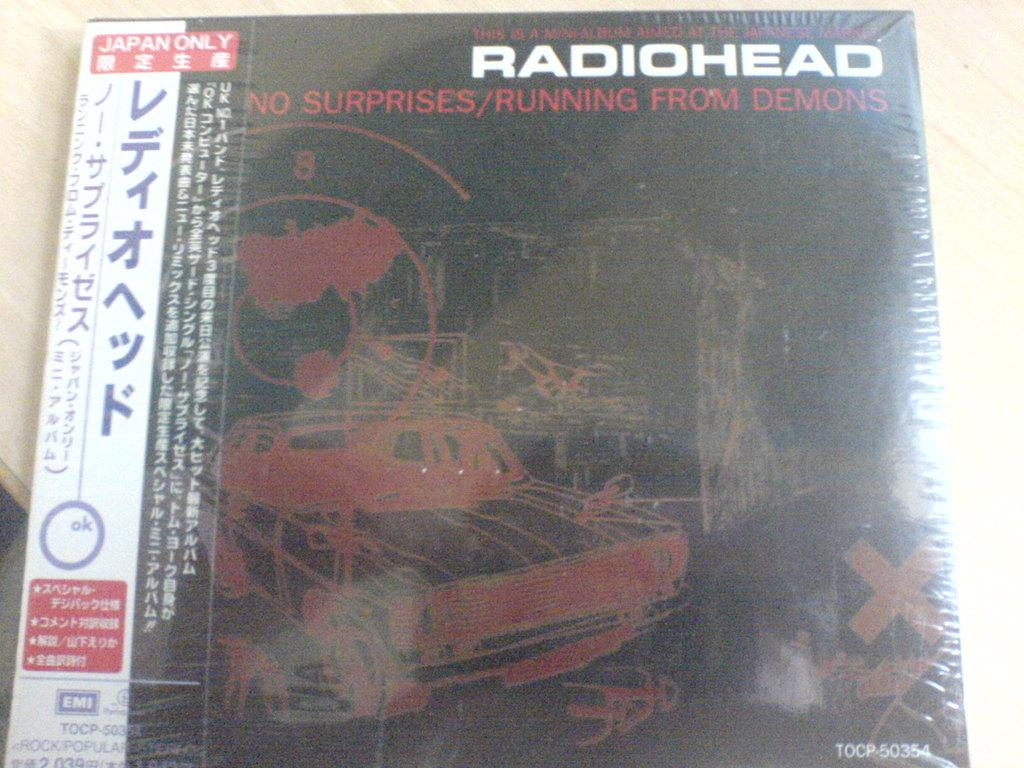<image>
Present a compact description of the photo's key features. A Radiohead album called No Surprises/Running from Demons for Japan only 